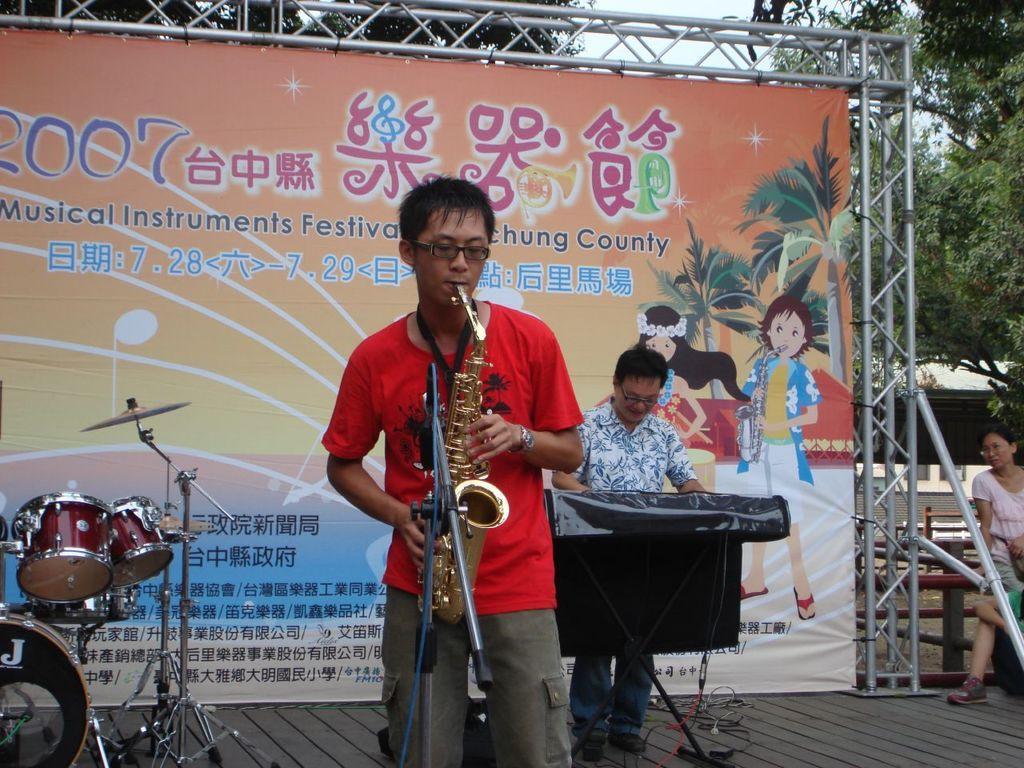In one or two sentences, can you explain what this image depicts? In this image a man wearing red t-shirt is playing musical instrument. In the background a man is playing keyboard. On the stage there are few other musical instruments and mics are there. In the background there is a banner. Here few people are there. back These are trees. 